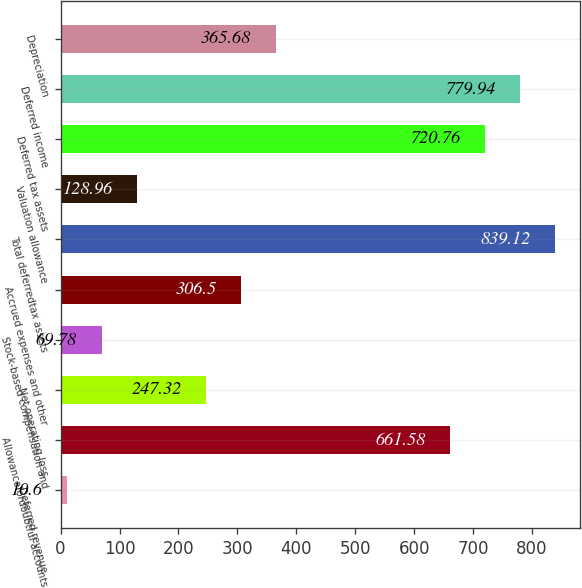<chart> <loc_0><loc_0><loc_500><loc_500><bar_chart><fcel>Deferred revenue<fcel>Allowancefordoubtful accounts<fcel>Net operating loss<fcel>Stock-based compensation and<fcel>Accrued expenses and other<fcel>Total deferredtax assets<fcel>Valuation allowance<fcel>Deferred tax assets<fcel>Deferred income<fcel>Depreciation<nl><fcel>10.6<fcel>661.58<fcel>247.32<fcel>69.78<fcel>306.5<fcel>839.12<fcel>128.96<fcel>720.76<fcel>779.94<fcel>365.68<nl></chart> 